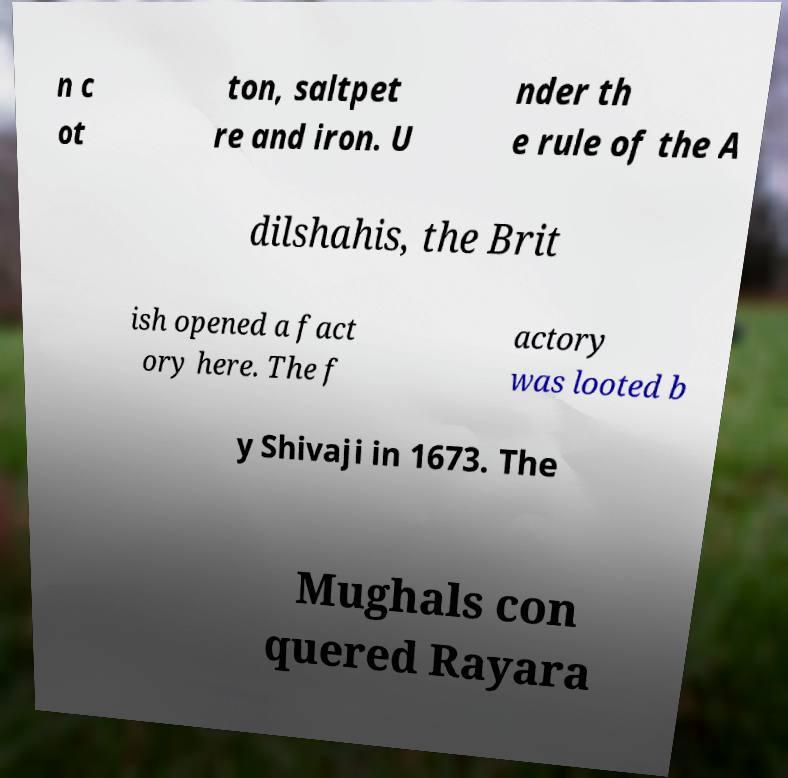What messages or text are displayed in this image? I need them in a readable, typed format. n c ot ton, saltpet re and iron. U nder th e rule of the A dilshahis, the Brit ish opened a fact ory here. The f actory was looted b y Shivaji in 1673. The Mughals con quered Rayara 